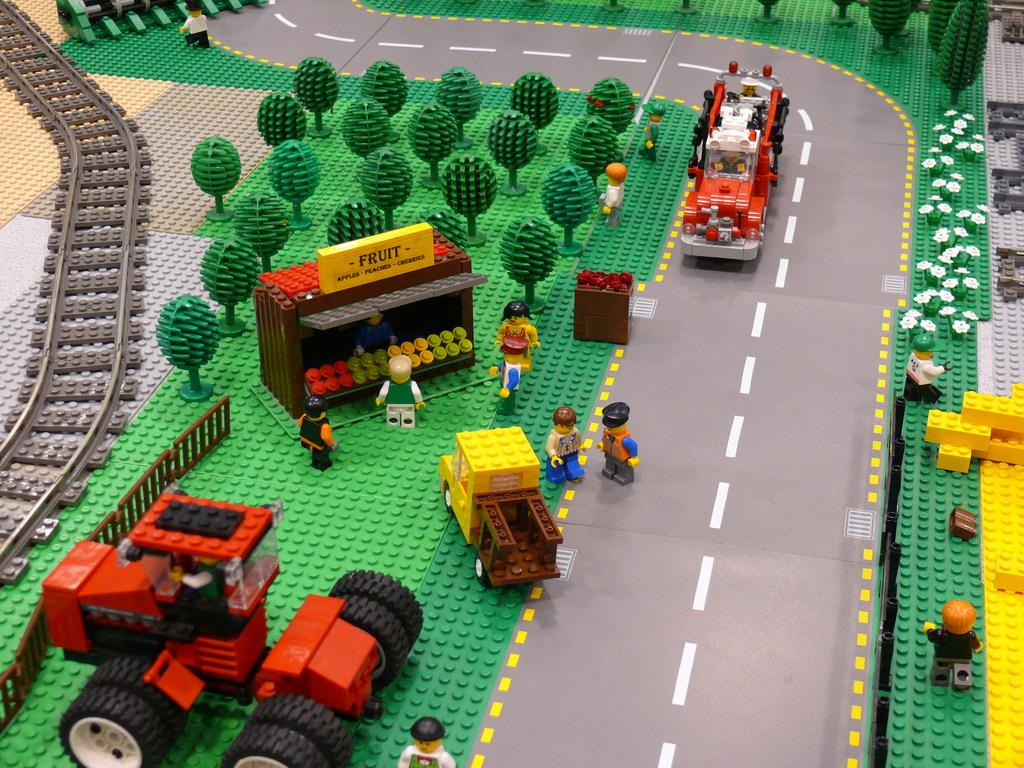Provide a one-sentence caption for the provided image. A Lego playmat showing market gardens and tractors and a fruit stand. 